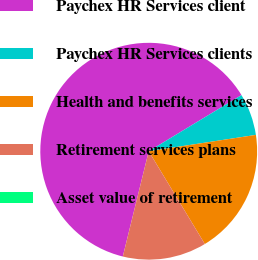<chart> <loc_0><loc_0><loc_500><loc_500><pie_chart><fcel>Paychex HR Services client<fcel>Paychex HR Services clients<fcel>Health and benefits services<fcel>Retirement services plans<fcel>Asset value of retirement<nl><fcel>62.5%<fcel>6.25%<fcel>18.75%<fcel>12.5%<fcel>0.0%<nl></chart> 